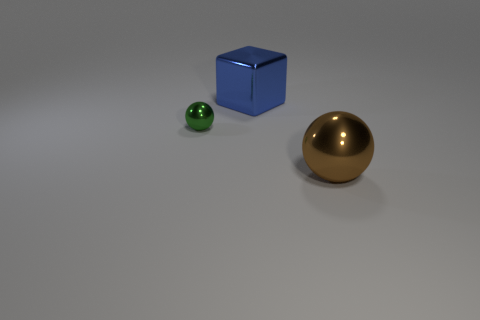Is there any other thing that is the same size as the green metallic sphere?
Your answer should be compact. No. What is the size of the metal sphere on the right side of the large thing left of the metallic thing that is right of the large block?
Your answer should be compact. Large. How many metallic objects are either large brown objects or tiny green objects?
Offer a very short reply. 2. What is the size of the blue object?
Provide a short and direct response. Large. What number of objects are blue metallic cubes or big metal objects left of the brown ball?
Your response must be concise. 1. What number of other things are there of the same color as the big ball?
Ensure brevity in your answer.  0. Do the brown metallic ball and the metallic thing behind the small ball have the same size?
Your answer should be very brief. Yes. There is a ball on the right side of the green metallic sphere; is its size the same as the tiny object?
Your answer should be very brief. No. How many other things are there of the same material as the large blue cube?
Keep it short and to the point. 2. Are there the same number of small spheres that are behind the green object and large metallic things in front of the large block?
Ensure brevity in your answer.  No. 